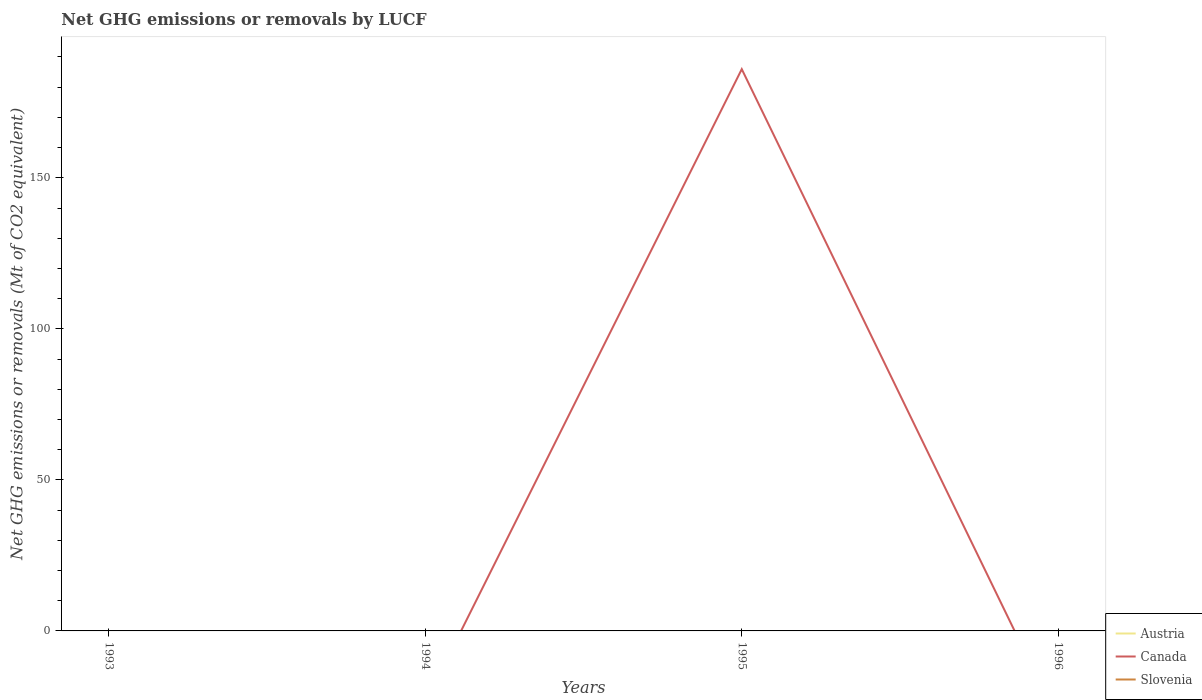How many different coloured lines are there?
Give a very brief answer. 1. Does the line corresponding to Austria intersect with the line corresponding to Slovenia?
Offer a very short reply. No. Across all years, what is the maximum net GHG emissions or removals by LUCF in Slovenia?
Your answer should be very brief. 0. What is the difference between the highest and the second highest net GHG emissions or removals by LUCF in Canada?
Ensure brevity in your answer.  185.97. What is the difference between the highest and the lowest net GHG emissions or removals by LUCF in Slovenia?
Keep it short and to the point. 0. How many lines are there?
Offer a very short reply. 1. How many years are there in the graph?
Provide a short and direct response. 4. What is the difference between two consecutive major ticks on the Y-axis?
Your answer should be very brief. 50. Does the graph contain any zero values?
Offer a terse response. Yes. Does the graph contain grids?
Offer a very short reply. No. Where does the legend appear in the graph?
Your answer should be very brief. Bottom right. How are the legend labels stacked?
Give a very brief answer. Vertical. What is the title of the graph?
Your answer should be very brief. Net GHG emissions or removals by LUCF. Does "Cyprus" appear as one of the legend labels in the graph?
Your response must be concise. No. What is the label or title of the Y-axis?
Offer a very short reply. Net GHG emissions or removals (Mt of CO2 equivalent). What is the Net GHG emissions or removals (Mt of CO2 equivalent) of Austria in 1993?
Your response must be concise. 0. What is the Net GHG emissions or removals (Mt of CO2 equivalent) in Canada in 1993?
Your response must be concise. 0. What is the Net GHG emissions or removals (Mt of CO2 equivalent) in Canada in 1995?
Make the answer very short. 185.97. What is the Net GHG emissions or removals (Mt of CO2 equivalent) in Canada in 1996?
Your answer should be compact. 0. What is the Net GHG emissions or removals (Mt of CO2 equivalent) of Slovenia in 1996?
Make the answer very short. 0. Across all years, what is the maximum Net GHG emissions or removals (Mt of CO2 equivalent) in Canada?
Offer a terse response. 185.97. What is the total Net GHG emissions or removals (Mt of CO2 equivalent) of Austria in the graph?
Give a very brief answer. 0. What is the total Net GHG emissions or removals (Mt of CO2 equivalent) of Canada in the graph?
Your response must be concise. 185.97. What is the average Net GHG emissions or removals (Mt of CO2 equivalent) of Canada per year?
Make the answer very short. 46.49. What is the average Net GHG emissions or removals (Mt of CO2 equivalent) of Slovenia per year?
Ensure brevity in your answer.  0. What is the difference between the highest and the lowest Net GHG emissions or removals (Mt of CO2 equivalent) of Canada?
Provide a succinct answer. 185.97. 